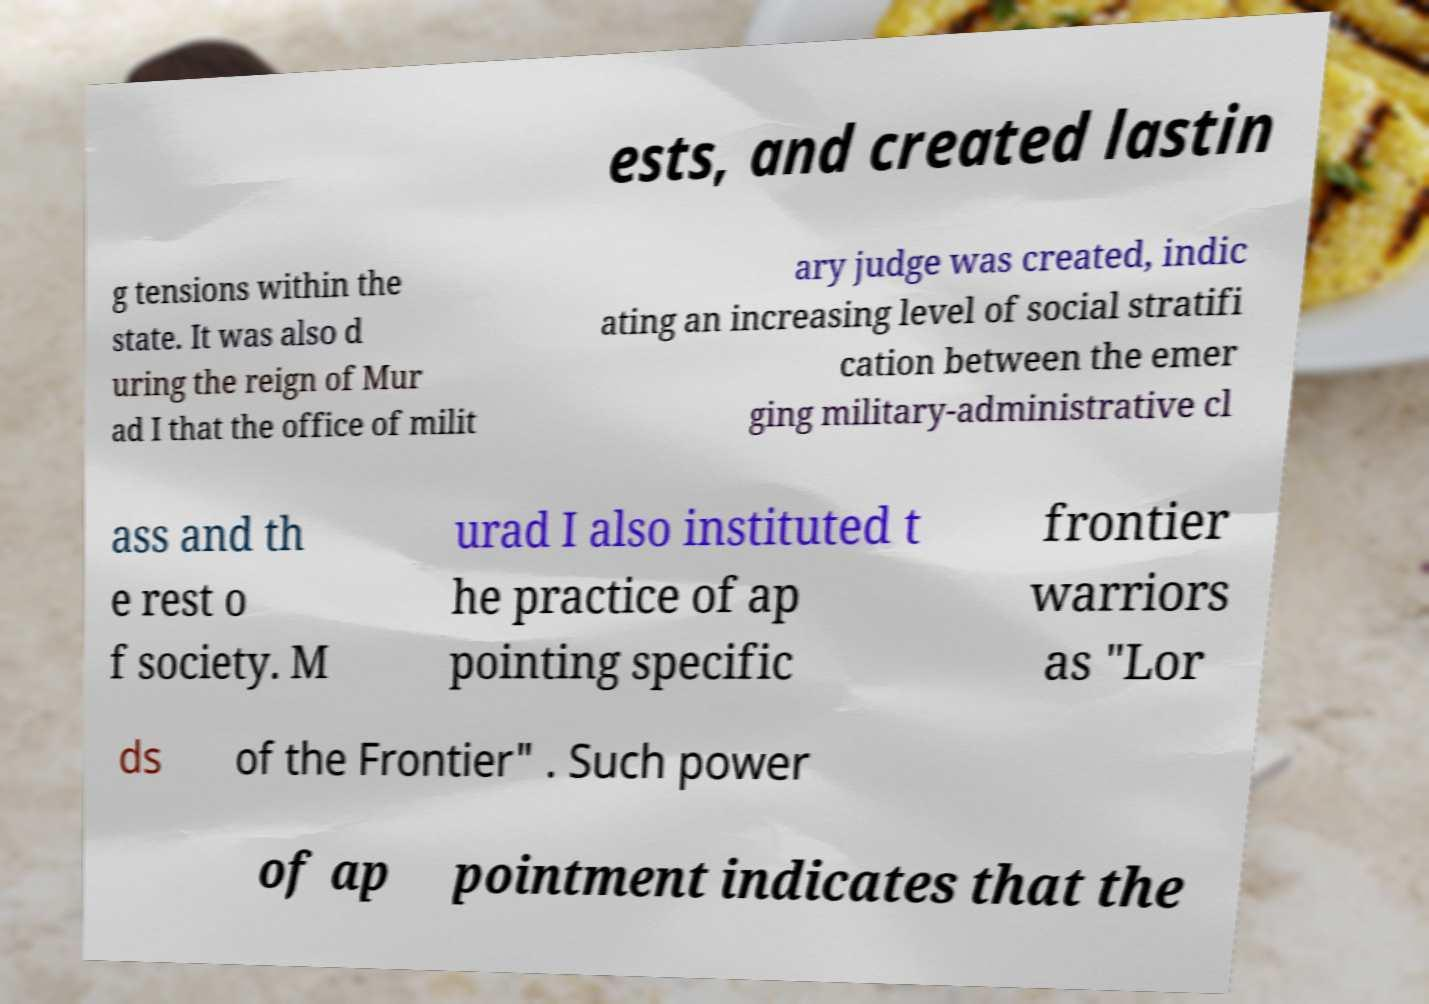There's text embedded in this image that I need extracted. Can you transcribe it verbatim? ests, and created lastin g tensions within the state. It was also d uring the reign of Mur ad I that the office of milit ary judge was created, indic ating an increasing level of social stratifi cation between the emer ging military-administrative cl ass and th e rest o f society. M urad I also instituted t he practice of ap pointing specific frontier warriors as "Lor ds of the Frontier" . Such power of ap pointment indicates that the 